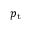Convert formula to latex. <formula><loc_0><loc_0><loc_500><loc_500>{ p _ { t } }</formula> 